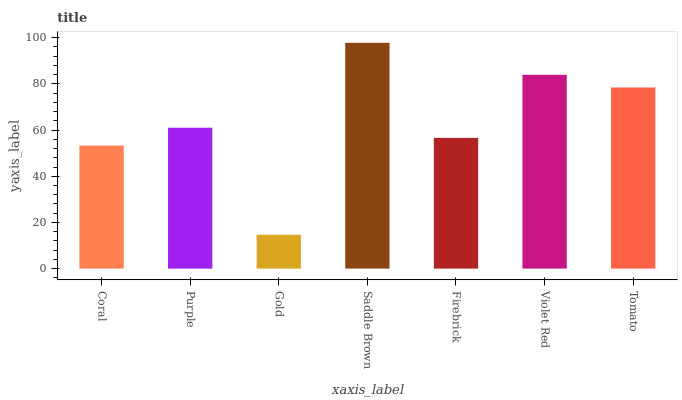Is Gold the minimum?
Answer yes or no. Yes. Is Saddle Brown the maximum?
Answer yes or no. Yes. Is Purple the minimum?
Answer yes or no. No. Is Purple the maximum?
Answer yes or no. No. Is Purple greater than Coral?
Answer yes or no. Yes. Is Coral less than Purple?
Answer yes or no. Yes. Is Coral greater than Purple?
Answer yes or no. No. Is Purple less than Coral?
Answer yes or no. No. Is Purple the high median?
Answer yes or no. Yes. Is Purple the low median?
Answer yes or no. Yes. Is Saddle Brown the high median?
Answer yes or no. No. Is Tomato the low median?
Answer yes or no. No. 